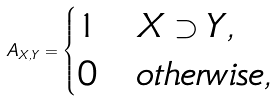<formula> <loc_0><loc_0><loc_500><loc_500>A _ { X , Y } = \begin{cases} 1 & X \supset Y , \\ 0 & o t h e r w i s e , \end{cases}</formula> 